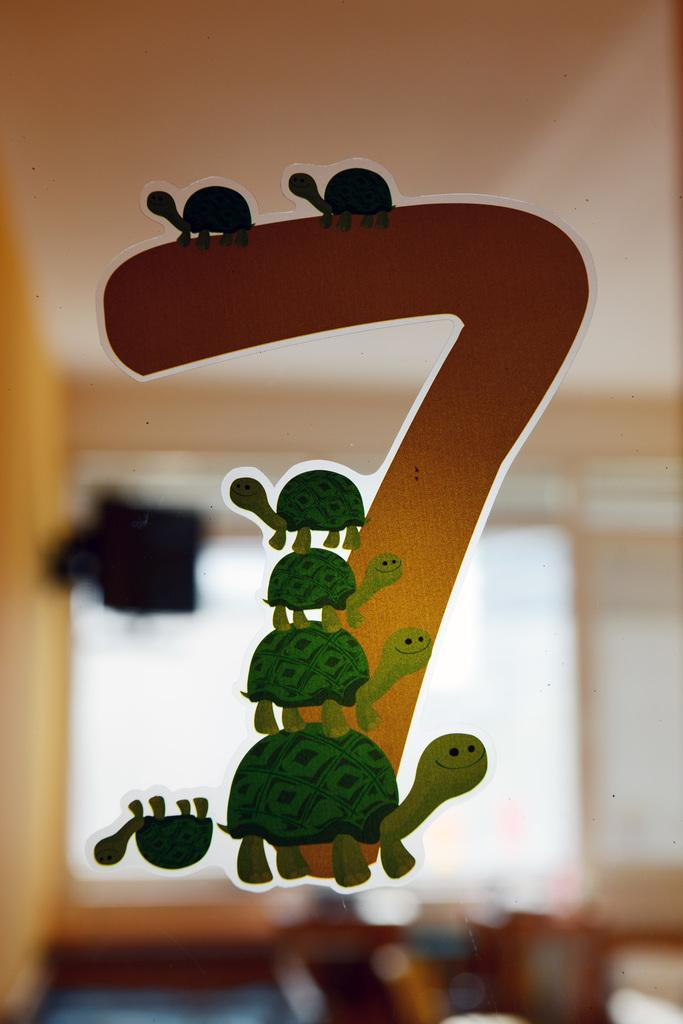What is present on the sticker in the image? There is a sticker in the image, and it has a seven number. What design is featured on the sticker? There is a group of turtles designed on the sticker. What type of field can be seen in the image? There is no field present in the image; it only features a sticker with a seven number and a group of turtles designed on it. What is the carpenter doing in the image? There is no carpenter present in the image. 